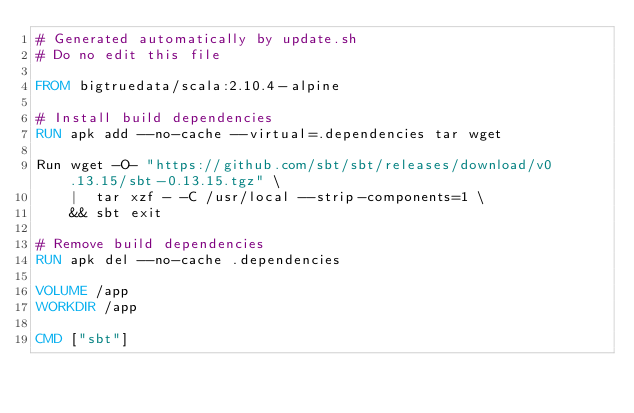Convert code to text. <code><loc_0><loc_0><loc_500><loc_500><_Dockerfile_># Generated automatically by update.sh
# Do no edit this file

FROM bigtruedata/scala:2.10.4-alpine

# Install build dependencies
RUN apk add --no-cache --virtual=.dependencies tar wget

Run wget -O- "https://github.com/sbt/sbt/releases/download/v0.13.15/sbt-0.13.15.tgz" \
    |  tar xzf - -C /usr/local --strip-components=1 \
    && sbt exit

# Remove build dependencies
RUN apk del --no-cache .dependencies

VOLUME /app
WORKDIR /app

CMD ["sbt"]
</code> 